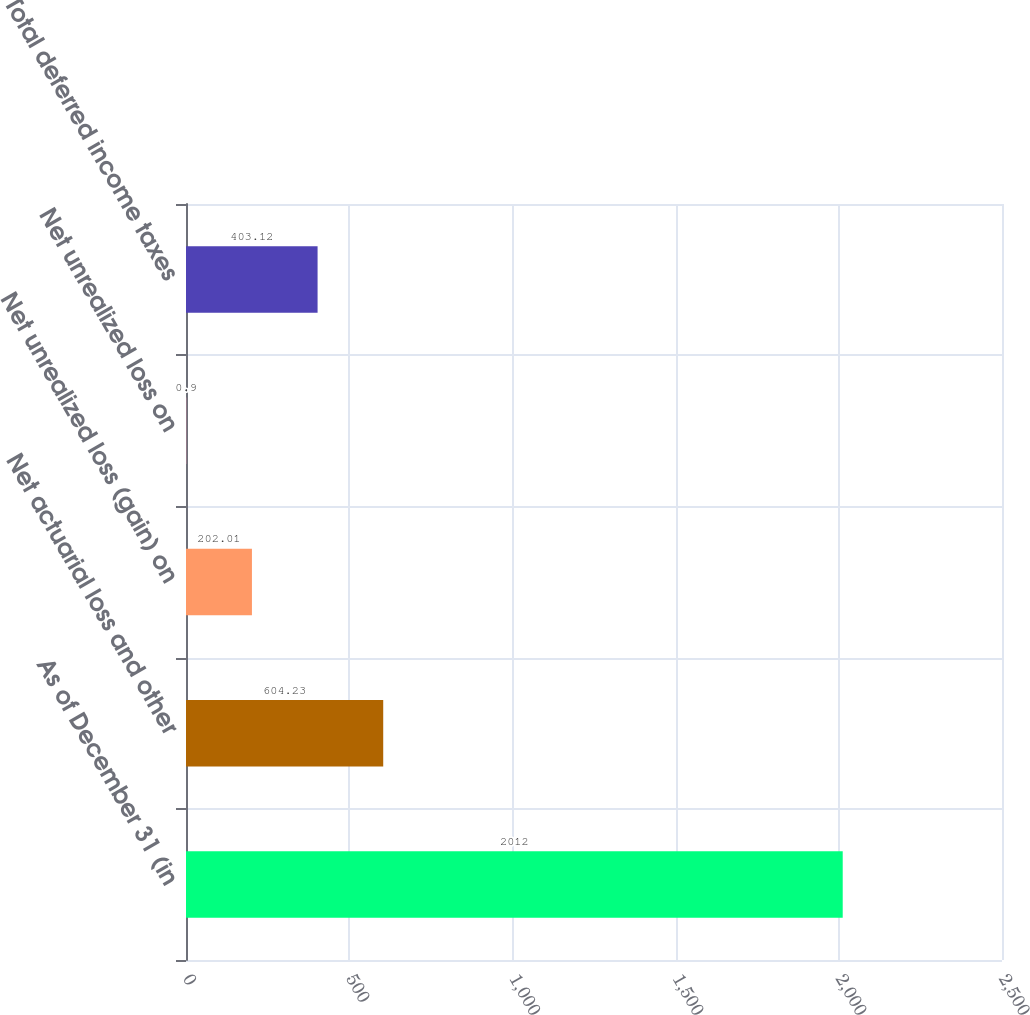<chart> <loc_0><loc_0><loc_500><loc_500><bar_chart><fcel>As of December 31 (in<fcel>Net actuarial loss and other<fcel>Net unrealized loss (gain) on<fcel>Net unrealized loss on<fcel>Total deferred income taxes<nl><fcel>2012<fcel>604.23<fcel>202.01<fcel>0.9<fcel>403.12<nl></chart> 